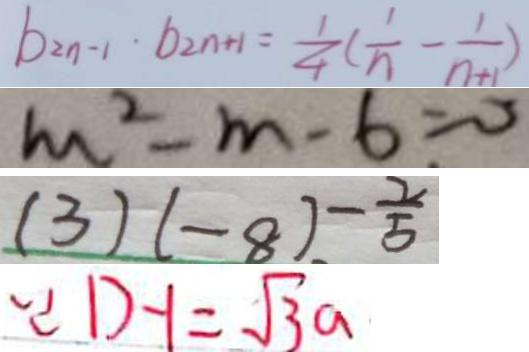<formula> <loc_0><loc_0><loc_500><loc_500>b _ { 2 n - 1 } \cdot b _ { 2 n + 1 } = \frac { 1 } { 4 } ( \frac { 1 } { n } - \frac { 1 } { n + 1 } ) 
 m ^ { 2 } - m - 6 = 0 
 ( 3 ) ( - 8 ) - \frac { 2 } { 5 } 
 \because D - 1 = \sqrt { 3 } a</formula> 